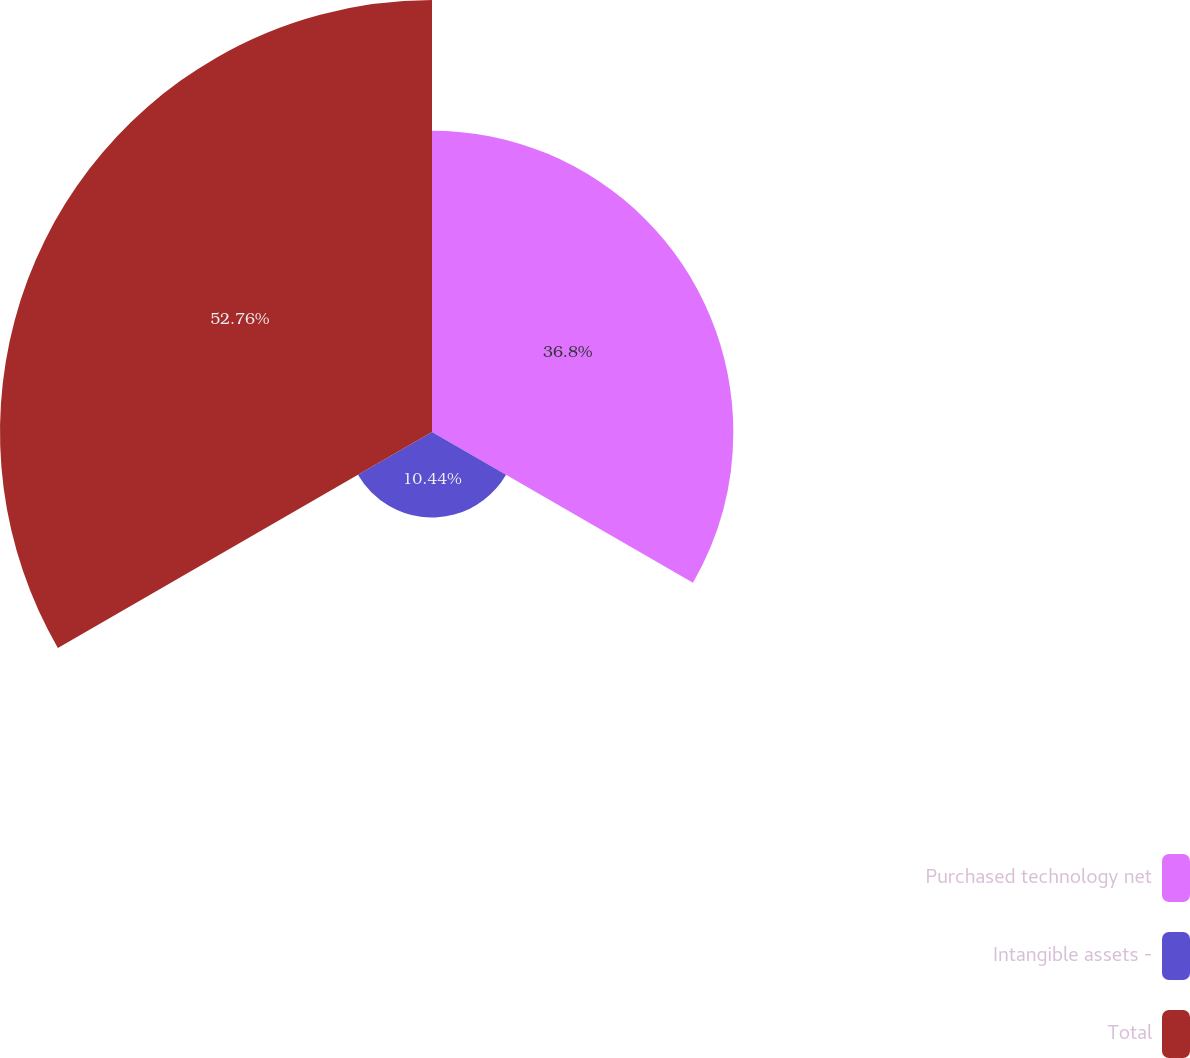Convert chart to OTSL. <chart><loc_0><loc_0><loc_500><loc_500><pie_chart><fcel>Purchased technology net<fcel>Intangible assets -<fcel>Total<nl><fcel>36.8%<fcel>10.44%<fcel>52.76%<nl></chart> 